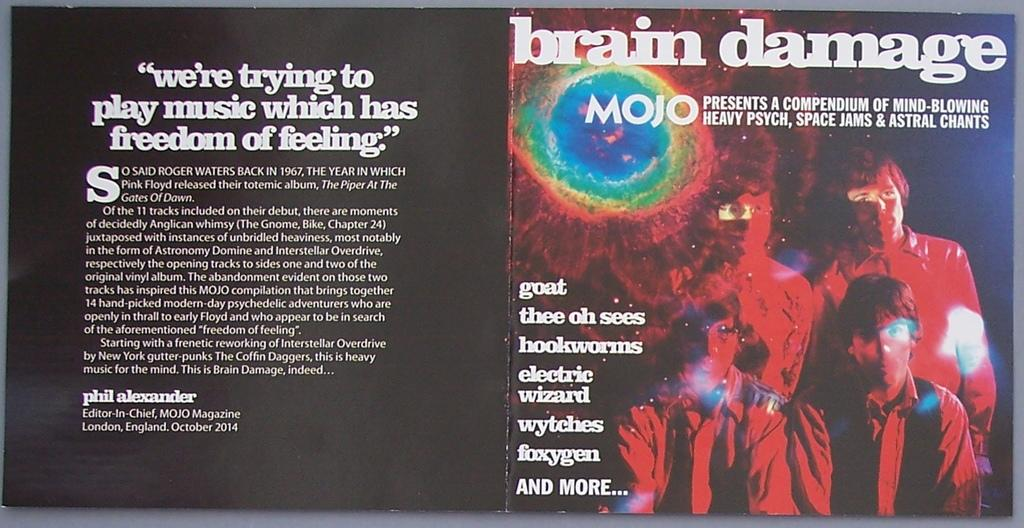<image>
Share a concise interpretation of the image provided. A CD cover by the group MOJO  is opened so you can see a message. 